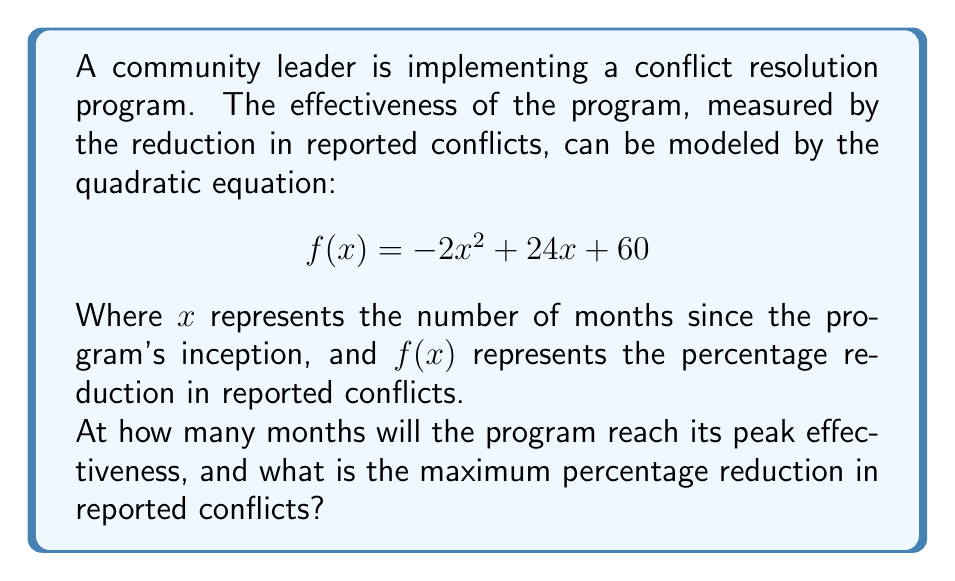Solve this math problem. To solve this problem, we need to find the vertex of the parabola represented by the quadratic equation. The vertex will give us the maximum point of the function, which corresponds to the peak effectiveness of the program.

For a quadratic equation in the form $f(x) = ax^2 + bx + c$, the x-coordinate of the vertex is given by $x = -\frac{b}{2a}$.

1. Identify the coefficients:
   $a = -2$, $b = 24$, $c = 60$

2. Calculate the x-coordinate of the vertex:
   $x = -\frac{b}{2a} = -\frac{24}{2(-2)} = -\frac{24}{-4} = 6$

This means the program will reach its peak effectiveness after 6 months.

3. To find the maximum percentage reduction, we need to calculate $f(6)$:
   $$ f(6) = -2(6)^2 + 24(6) + 60 $$
   $$ = -2(36) + 144 + 60 $$
   $$ = -72 + 144 + 60 $$
   $$ = 132 $$

Therefore, the maximum percentage reduction in reported conflicts is 132%.
Answer: The program will reach its peak effectiveness after 6 months, with a maximum percentage reduction in reported conflicts of 132%. 